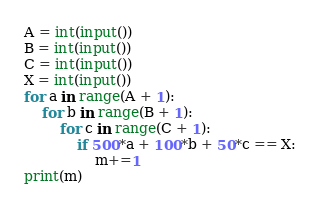Convert code to text. <code><loc_0><loc_0><loc_500><loc_500><_Python_>A = int(input())
B = int(input())
C = int(input())
X = int(input())
for a in range(A + 1):
    for b in range(B + 1):
        for c in range(C + 1):
            if 500*a + 100*b + 50*c == X:
                m+=1
print(m)</code> 